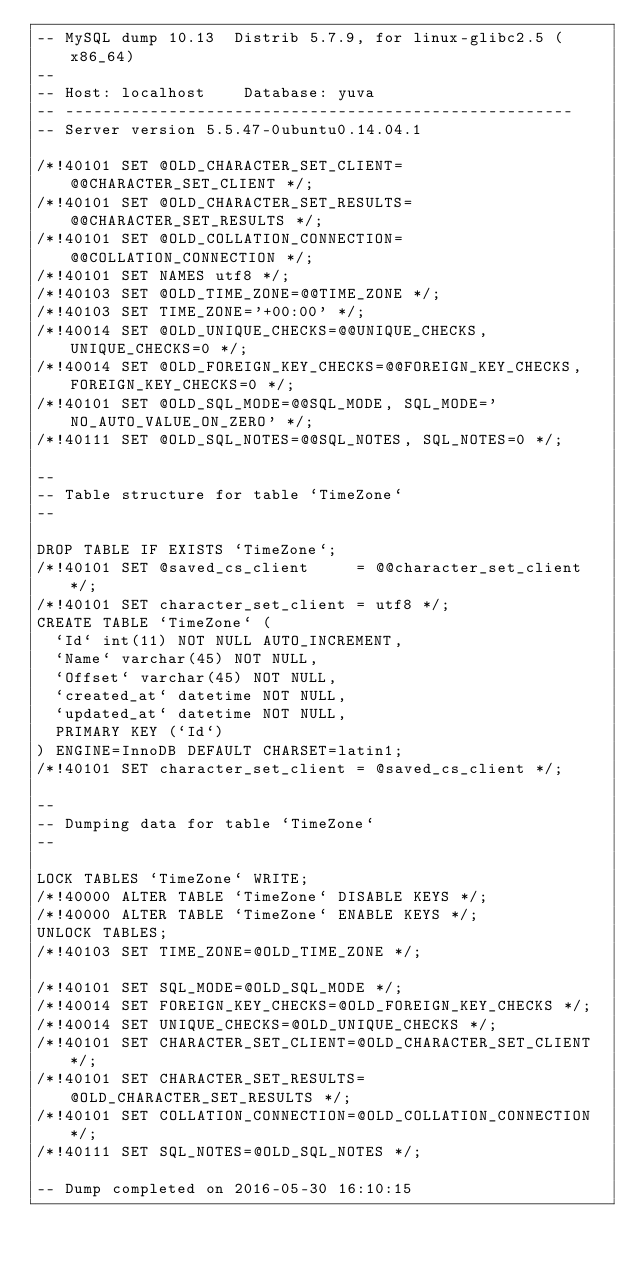<code> <loc_0><loc_0><loc_500><loc_500><_SQL_>-- MySQL dump 10.13  Distrib 5.7.9, for linux-glibc2.5 (x86_64)
--
-- Host: localhost    Database: yuva
-- ------------------------------------------------------
-- Server version	5.5.47-0ubuntu0.14.04.1

/*!40101 SET @OLD_CHARACTER_SET_CLIENT=@@CHARACTER_SET_CLIENT */;
/*!40101 SET @OLD_CHARACTER_SET_RESULTS=@@CHARACTER_SET_RESULTS */;
/*!40101 SET @OLD_COLLATION_CONNECTION=@@COLLATION_CONNECTION */;
/*!40101 SET NAMES utf8 */;
/*!40103 SET @OLD_TIME_ZONE=@@TIME_ZONE */;
/*!40103 SET TIME_ZONE='+00:00' */;
/*!40014 SET @OLD_UNIQUE_CHECKS=@@UNIQUE_CHECKS, UNIQUE_CHECKS=0 */;
/*!40014 SET @OLD_FOREIGN_KEY_CHECKS=@@FOREIGN_KEY_CHECKS, FOREIGN_KEY_CHECKS=0 */;
/*!40101 SET @OLD_SQL_MODE=@@SQL_MODE, SQL_MODE='NO_AUTO_VALUE_ON_ZERO' */;
/*!40111 SET @OLD_SQL_NOTES=@@SQL_NOTES, SQL_NOTES=0 */;

--
-- Table structure for table `TimeZone`
--

DROP TABLE IF EXISTS `TimeZone`;
/*!40101 SET @saved_cs_client     = @@character_set_client */;
/*!40101 SET character_set_client = utf8 */;
CREATE TABLE `TimeZone` (
  `Id` int(11) NOT NULL AUTO_INCREMENT,
  `Name` varchar(45) NOT NULL,
  `Offset` varchar(45) NOT NULL,
  `created_at` datetime NOT NULL,
  `updated_at` datetime NOT NULL,
  PRIMARY KEY (`Id`)
) ENGINE=InnoDB DEFAULT CHARSET=latin1;
/*!40101 SET character_set_client = @saved_cs_client */;

--
-- Dumping data for table `TimeZone`
--

LOCK TABLES `TimeZone` WRITE;
/*!40000 ALTER TABLE `TimeZone` DISABLE KEYS */;
/*!40000 ALTER TABLE `TimeZone` ENABLE KEYS */;
UNLOCK TABLES;
/*!40103 SET TIME_ZONE=@OLD_TIME_ZONE */;

/*!40101 SET SQL_MODE=@OLD_SQL_MODE */;
/*!40014 SET FOREIGN_KEY_CHECKS=@OLD_FOREIGN_KEY_CHECKS */;
/*!40014 SET UNIQUE_CHECKS=@OLD_UNIQUE_CHECKS */;
/*!40101 SET CHARACTER_SET_CLIENT=@OLD_CHARACTER_SET_CLIENT */;
/*!40101 SET CHARACTER_SET_RESULTS=@OLD_CHARACTER_SET_RESULTS */;
/*!40101 SET COLLATION_CONNECTION=@OLD_COLLATION_CONNECTION */;
/*!40111 SET SQL_NOTES=@OLD_SQL_NOTES */;

-- Dump completed on 2016-05-30 16:10:15
</code> 